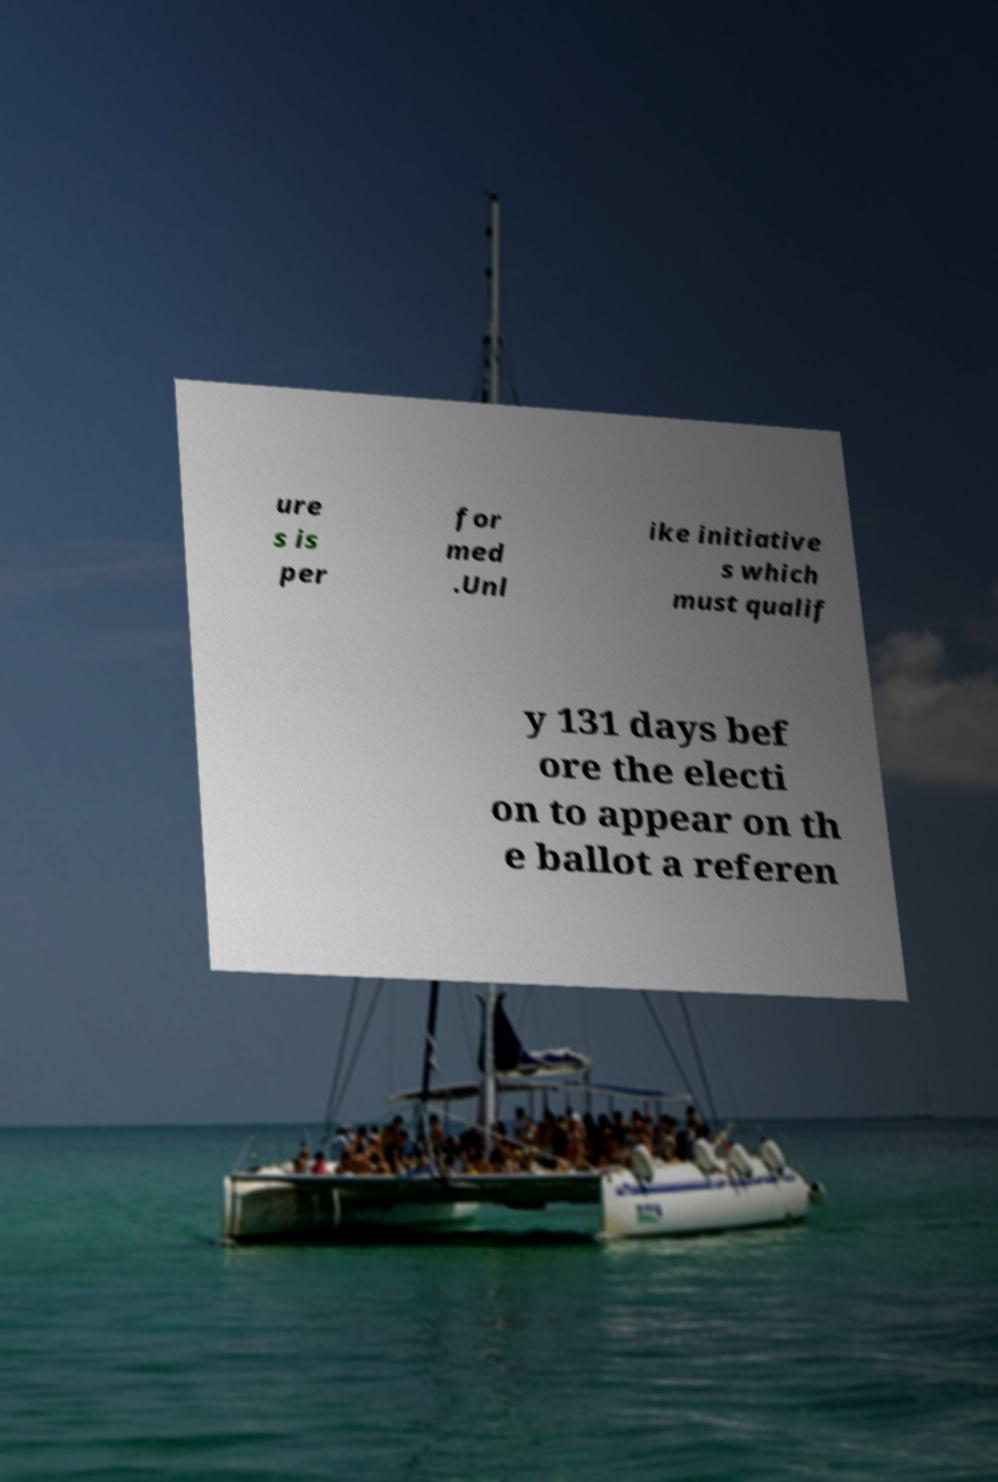Could you assist in decoding the text presented in this image and type it out clearly? ure s is per for med .Unl ike initiative s which must qualif y 131 days bef ore the electi on to appear on th e ballot a referen 